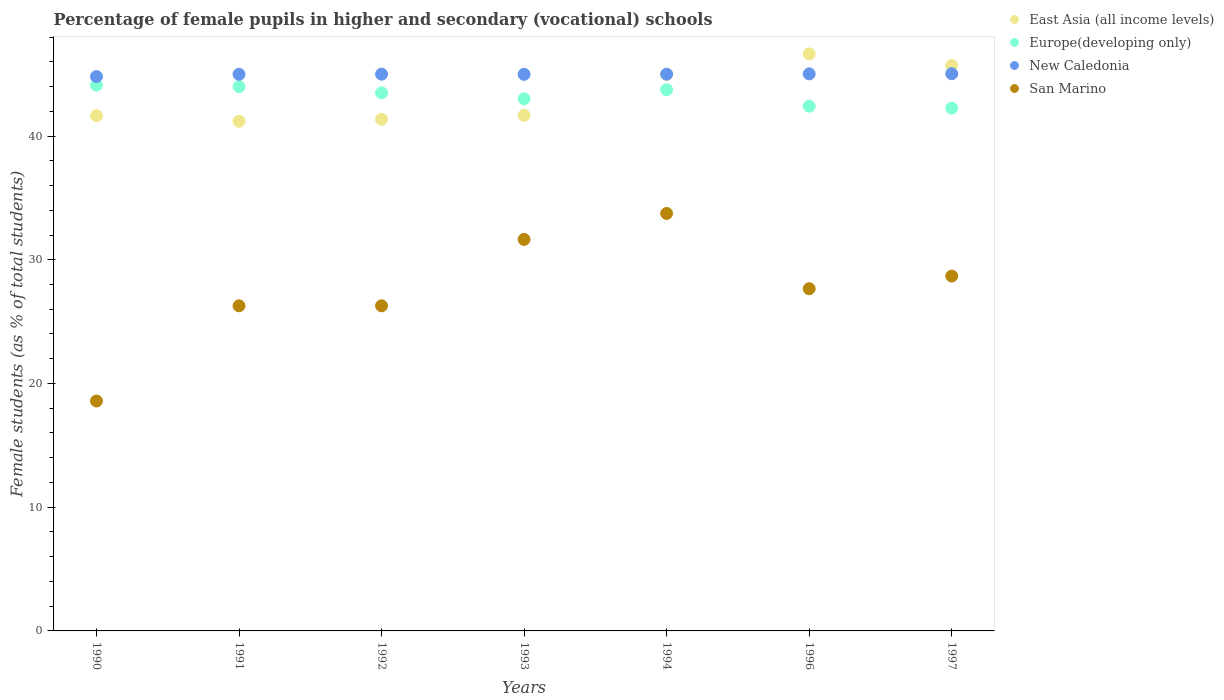Is the number of dotlines equal to the number of legend labels?
Give a very brief answer. Yes. What is the percentage of female pupils in higher and secondary schools in San Marino in 1992?
Your answer should be very brief. 26.28. Across all years, what is the maximum percentage of female pupils in higher and secondary schools in East Asia (all income levels)?
Your answer should be very brief. 46.64. Across all years, what is the minimum percentage of female pupils in higher and secondary schools in San Marino?
Offer a very short reply. 18.58. In which year was the percentage of female pupils in higher and secondary schools in Europe(developing only) maximum?
Provide a succinct answer. 1990. What is the total percentage of female pupils in higher and secondary schools in New Caledonia in the graph?
Keep it short and to the point. 314.85. What is the difference between the percentage of female pupils in higher and secondary schools in East Asia (all income levels) in 1991 and that in 1992?
Provide a succinct answer. -0.16. What is the difference between the percentage of female pupils in higher and secondary schools in San Marino in 1994 and the percentage of female pupils in higher and secondary schools in Europe(developing only) in 1996?
Your response must be concise. -8.67. What is the average percentage of female pupils in higher and secondary schools in East Asia (all income levels) per year?
Your response must be concise. 43.31. In the year 1991, what is the difference between the percentage of female pupils in higher and secondary schools in East Asia (all income levels) and percentage of female pupils in higher and secondary schools in New Caledonia?
Your answer should be compact. -3.8. In how many years, is the percentage of female pupils in higher and secondary schools in New Caledonia greater than 20 %?
Your answer should be compact. 7. What is the ratio of the percentage of female pupils in higher and secondary schools in San Marino in 1993 to that in 1996?
Your answer should be very brief. 1.14. Is the difference between the percentage of female pupils in higher and secondary schools in East Asia (all income levels) in 1991 and 1994 greater than the difference between the percentage of female pupils in higher and secondary schools in New Caledonia in 1991 and 1994?
Your response must be concise. No. What is the difference between the highest and the second highest percentage of female pupils in higher and secondary schools in East Asia (all income levels)?
Offer a terse response. 0.94. What is the difference between the highest and the lowest percentage of female pupils in higher and secondary schools in East Asia (all income levels)?
Offer a terse response. 5.44. Is the percentage of female pupils in higher and secondary schools in San Marino strictly greater than the percentage of female pupils in higher and secondary schools in East Asia (all income levels) over the years?
Provide a succinct answer. No. Is the percentage of female pupils in higher and secondary schools in San Marino strictly less than the percentage of female pupils in higher and secondary schools in Europe(developing only) over the years?
Give a very brief answer. Yes. How many dotlines are there?
Offer a terse response. 4. What is the difference between two consecutive major ticks on the Y-axis?
Offer a very short reply. 10. Are the values on the major ticks of Y-axis written in scientific E-notation?
Give a very brief answer. No. Does the graph contain any zero values?
Your answer should be compact. No. Does the graph contain grids?
Your answer should be very brief. No. Where does the legend appear in the graph?
Make the answer very short. Top right. How are the legend labels stacked?
Your response must be concise. Vertical. What is the title of the graph?
Your response must be concise. Percentage of female pupils in higher and secondary (vocational) schools. Does "Sierra Leone" appear as one of the legend labels in the graph?
Keep it short and to the point. No. What is the label or title of the X-axis?
Provide a short and direct response. Years. What is the label or title of the Y-axis?
Provide a succinct answer. Female students (as % of total students). What is the Female students (as % of total students) of East Asia (all income levels) in 1990?
Your answer should be compact. 41.65. What is the Female students (as % of total students) in Europe(developing only) in 1990?
Give a very brief answer. 44.11. What is the Female students (as % of total students) of New Caledonia in 1990?
Your answer should be compact. 44.81. What is the Female students (as % of total students) in San Marino in 1990?
Give a very brief answer. 18.58. What is the Female students (as % of total students) in East Asia (all income levels) in 1991?
Provide a short and direct response. 41.2. What is the Female students (as % of total students) in Europe(developing only) in 1991?
Make the answer very short. 44. What is the Female students (as % of total students) of New Caledonia in 1991?
Give a very brief answer. 44.99. What is the Female students (as % of total students) of San Marino in 1991?
Your answer should be very brief. 26.28. What is the Female students (as % of total students) of East Asia (all income levels) in 1992?
Keep it short and to the point. 41.35. What is the Female students (as % of total students) in Europe(developing only) in 1992?
Your answer should be compact. 43.49. What is the Female students (as % of total students) in San Marino in 1992?
Provide a short and direct response. 26.28. What is the Female students (as % of total students) in East Asia (all income levels) in 1993?
Keep it short and to the point. 41.68. What is the Female students (as % of total students) of Europe(developing only) in 1993?
Your answer should be very brief. 43.01. What is the Female students (as % of total students) of New Caledonia in 1993?
Your response must be concise. 44.99. What is the Female students (as % of total students) in San Marino in 1993?
Provide a short and direct response. 31.65. What is the Female students (as % of total students) of East Asia (all income levels) in 1994?
Make the answer very short. 44.98. What is the Female students (as % of total students) of Europe(developing only) in 1994?
Your answer should be compact. 43.75. What is the Female students (as % of total students) of New Caledonia in 1994?
Offer a terse response. 45. What is the Female students (as % of total students) of San Marino in 1994?
Provide a succinct answer. 33.74. What is the Female students (as % of total students) of East Asia (all income levels) in 1996?
Your answer should be compact. 46.64. What is the Female students (as % of total students) in Europe(developing only) in 1996?
Your answer should be very brief. 42.41. What is the Female students (as % of total students) in New Caledonia in 1996?
Offer a very short reply. 45.03. What is the Female students (as % of total students) in San Marino in 1996?
Give a very brief answer. 27.66. What is the Female students (as % of total students) in East Asia (all income levels) in 1997?
Give a very brief answer. 45.7. What is the Female students (as % of total students) of Europe(developing only) in 1997?
Your answer should be very brief. 42.26. What is the Female students (as % of total students) of New Caledonia in 1997?
Your answer should be very brief. 45.04. What is the Female students (as % of total students) in San Marino in 1997?
Provide a short and direct response. 28.68. Across all years, what is the maximum Female students (as % of total students) in East Asia (all income levels)?
Offer a very short reply. 46.64. Across all years, what is the maximum Female students (as % of total students) in Europe(developing only)?
Your answer should be very brief. 44.11. Across all years, what is the maximum Female students (as % of total students) in New Caledonia?
Keep it short and to the point. 45.04. Across all years, what is the maximum Female students (as % of total students) of San Marino?
Ensure brevity in your answer.  33.74. Across all years, what is the minimum Female students (as % of total students) in East Asia (all income levels)?
Your answer should be compact. 41.2. Across all years, what is the minimum Female students (as % of total students) in Europe(developing only)?
Give a very brief answer. 42.26. Across all years, what is the minimum Female students (as % of total students) of New Caledonia?
Offer a very short reply. 44.81. Across all years, what is the minimum Female students (as % of total students) in San Marino?
Keep it short and to the point. 18.58. What is the total Female students (as % of total students) in East Asia (all income levels) in the graph?
Give a very brief answer. 303.19. What is the total Female students (as % of total students) in Europe(developing only) in the graph?
Offer a terse response. 303.03. What is the total Female students (as % of total students) in New Caledonia in the graph?
Provide a succinct answer. 314.85. What is the total Female students (as % of total students) in San Marino in the graph?
Keep it short and to the point. 192.87. What is the difference between the Female students (as % of total students) of East Asia (all income levels) in 1990 and that in 1991?
Provide a succinct answer. 0.45. What is the difference between the Female students (as % of total students) in Europe(developing only) in 1990 and that in 1991?
Your answer should be very brief. 0.11. What is the difference between the Female students (as % of total students) in New Caledonia in 1990 and that in 1991?
Provide a succinct answer. -0.19. What is the difference between the Female students (as % of total students) in San Marino in 1990 and that in 1991?
Your response must be concise. -7.69. What is the difference between the Female students (as % of total students) in East Asia (all income levels) in 1990 and that in 1992?
Offer a terse response. 0.29. What is the difference between the Female students (as % of total students) of Europe(developing only) in 1990 and that in 1992?
Provide a succinct answer. 0.62. What is the difference between the Female students (as % of total students) in New Caledonia in 1990 and that in 1992?
Provide a succinct answer. -0.19. What is the difference between the Female students (as % of total students) in San Marino in 1990 and that in 1992?
Keep it short and to the point. -7.69. What is the difference between the Female students (as % of total students) of East Asia (all income levels) in 1990 and that in 1993?
Offer a terse response. -0.03. What is the difference between the Female students (as % of total students) in Europe(developing only) in 1990 and that in 1993?
Make the answer very short. 1.1. What is the difference between the Female students (as % of total students) of New Caledonia in 1990 and that in 1993?
Your response must be concise. -0.18. What is the difference between the Female students (as % of total students) in San Marino in 1990 and that in 1993?
Ensure brevity in your answer.  -13.06. What is the difference between the Female students (as % of total students) in East Asia (all income levels) in 1990 and that in 1994?
Keep it short and to the point. -3.33. What is the difference between the Female students (as % of total students) in Europe(developing only) in 1990 and that in 1994?
Keep it short and to the point. 0.36. What is the difference between the Female students (as % of total students) in New Caledonia in 1990 and that in 1994?
Your answer should be compact. -0.19. What is the difference between the Female students (as % of total students) of San Marino in 1990 and that in 1994?
Ensure brevity in your answer.  -15.16. What is the difference between the Female students (as % of total students) of East Asia (all income levels) in 1990 and that in 1996?
Offer a very short reply. -4.99. What is the difference between the Female students (as % of total students) of Europe(developing only) in 1990 and that in 1996?
Your answer should be compact. 1.7. What is the difference between the Female students (as % of total students) of New Caledonia in 1990 and that in 1996?
Offer a terse response. -0.22. What is the difference between the Female students (as % of total students) of San Marino in 1990 and that in 1996?
Provide a short and direct response. -9.08. What is the difference between the Female students (as % of total students) in East Asia (all income levels) in 1990 and that in 1997?
Provide a short and direct response. -4.05. What is the difference between the Female students (as % of total students) in Europe(developing only) in 1990 and that in 1997?
Provide a succinct answer. 1.85. What is the difference between the Female students (as % of total students) in New Caledonia in 1990 and that in 1997?
Provide a succinct answer. -0.23. What is the difference between the Female students (as % of total students) of San Marino in 1990 and that in 1997?
Your answer should be very brief. -10.1. What is the difference between the Female students (as % of total students) of East Asia (all income levels) in 1991 and that in 1992?
Make the answer very short. -0.16. What is the difference between the Female students (as % of total students) of Europe(developing only) in 1991 and that in 1992?
Your answer should be compact. 0.51. What is the difference between the Female students (as % of total students) in New Caledonia in 1991 and that in 1992?
Offer a terse response. -0.01. What is the difference between the Female students (as % of total students) in San Marino in 1991 and that in 1992?
Make the answer very short. 0. What is the difference between the Female students (as % of total students) of East Asia (all income levels) in 1991 and that in 1993?
Provide a short and direct response. -0.48. What is the difference between the Female students (as % of total students) of Europe(developing only) in 1991 and that in 1993?
Offer a terse response. 0.99. What is the difference between the Female students (as % of total students) in New Caledonia in 1991 and that in 1993?
Offer a very short reply. 0.01. What is the difference between the Female students (as % of total students) of San Marino in 1991 and that in 1993?
Provide a short and direct response. -5.37. What is the difference between the Female students (as % of total students) of East Asia (all income levels) in 1991 and that in 1994?
Provide a short and direct response. -3.79. What is the difference between the Female students (as % of total students) of Europe(developing only) in 1991 and that in 1994?
Make the answer very short. 0.25. What is the difference between the Female students (as % of total students) of New Caledonia in 1991 and that in 1994?
Offer a very short reply. -0.01. What is the difference between the Female students (as % of total students) in San Marino in 1991 and that in 1994?
Provide a succinct answer. -7.46. What is the difference between the Female students (as % of total students) of East Asia (all income levels) in 1991 and that in 1996?
Your response must be concise. -5.44. What is the difference between the Female students (as % of total students) in Europe(developing only) in 1991 and that in 1996?
Your answer should be very brief. 1.59. What is the difference between the Female students (as % of total students) in New Caledonia in 1991 and that in 1996?
Keep it short and to the point. -0.03. What is the difference between the Female students (as % of total students) in San Marino in 1991 and that in 1996?
Keep it short and to the point. -1.38. What is the difference between the Female students (as % of total students) of East Asia (all income levels) in 1991 and that in 1997?
Provide a short and direct response. -4.51. What is the difference between the Female students (as % of total students) of Europe(developing only) in 1991 and that in 1997?
Your response must be concise. 1.74. What is the difference between the Female students (as % of total students) of New Caledonia in 1991 and that in 1997?
Provide a short and direct response. -0.05. What is the difference between the Female students (as % of total students) of San Marino in 1991 and that in 1997?
Offer a very short reply. -2.4. What is the difference between the Female students (as % of total students) in East Asia (all income levels) in 1992 and that in 1993?
Provide a succinct answer. -0.32. What is the difference between the Female students (as % of total students) in Europe(developing only) in 1992 and that in 1993?
Offer a very short reply. 0.48. What is the difference between the Female students (as % of total students) of New Caledonia in 1992 and that in 1993?
Provide a succinct answer. 0.01. What is the difference between the Female students (as % of total students) in San Marino in 1992 and that in 1993?
Your answer should be very brief. -5.37. What is the difference between the Female students (as % of total students) in East Asia (all income levels) in 1992 and that in 1994?
Provide a succinct answer. -3.63. What is the difference between the Female students (as % of total students) in Europe(developing only) in 1992 and that in 1994?
Keep it short and to the point. -0.26. What is the difference between the Female students (as % of total students) of San Marino in 1992 and that in 1994?
Your answer should be very brief. -7.46. What is the difference between the Female students (as % of total students) in East Asia (all income levels) in 1992 and that in 1996?
Your response must be concise. -5.28. What is the difference between the Female students (as % of total students) of Europe(developing only) in 1992 and that in 1996?
Your response must be concise. 1.08. What is the difference between the Female students (as % of total students) in New Caledonia in 1992 and that in 1996?
Your answer should be very brief. -0.03. What is the difference between the Female students (as % of total students) of San Marino in 1992 and that in 1996?
Keep it short and to the point. -1.38. What is the difference between the Female students (as % of total students) in East Asia (all income levels) in 1992 and that in 1997?
Your answer should be compact. -4.35. What is the difference between the Female students (as % of total students) of Europe(developing only) in 1992 and that in 1997?
Offer a very short reply. 1.23. What is the difference between the Female students (as % of total students) of New Caledonia in 1992 and that in 1997?
Offer a very short reply. -0.04. What is the difference between the Female students (as % of total students) of San Marino in 1992 and that in 1997?
Your response must be concise. -2.4. What is the difference between the Female students (as % of total students) of East Asia (all income levels) in 1993 and that in 1994?
Keep it short and to the point. -3.3. What is the difference between the Female students (as % of total students) in Europe(developing only) in 1993 and that in 1994?
Your response must be concise. -0.74. What is the difference between the Female students (as % of total students) in New Caledonia in 1993 and that in 1994?
Keep it short and to the point. -0.01. What is the difference between the Female students (as % of total students) in San Marino in 1993 and that in 1994?
Your answer should be compact. -2.1. What is the difference between the Female students (as % of total students) of East Asia (all income levels) in 1993 and that in 1996?
Your answer should be compact. -4.96. What is the difference between the Female students (as % of total students) of Europe(developing only) in 1993 and that in 1996?
Ensure brevity in your answer.  0.59. What is the difference between the Female students (as % of total students) in New Caledonia in 1993 and that in 1996?
Offer a terse response. -0.04. What is the difference between the Female students (as % of total students) in San Marino in 1993 and that in 1996?
Make the answer very short. 3.99. What is the difference between the Female students (as % of total students) of East Asia (all income levels) in 1993 and that in 1997?
Offer a very short reply. -4.02. What is the difference between the Female students (as % of total students) in Europe(developing only) in 1993 and that in 1997?
Provide a short and direct response. 0.75. What is the difference between the Female students (as % of total students) of New Caledonia in 1993 and that in 1997?
Offer a terse response. -0.05. What is the difference between the Female students (as % of total students) of San Marino in 1993 and that in 1997?
Make the answer very short. 2.96. What is the difference between the Female students (as % of total students) in East Asia (all income levels) in 1994 and that in 1996?
Ensure brevity in your answer.  -1.65. What is the difference between the Female students (as % of total students) in Europe(developing only) in 1994 and that in 1996?
Your response must be concise. 1.33. What is the difference between the Female students (as % of total students) in New Caledonia in 1994 and that in 1996?
Your response must be concise. -0.03. What is the difference between the Female students (as % of total students) in San Marino in 1994 and that in 1996?
Keep it short and to the point. 6.08. What is the difference between the Female students (as % of total students) of East Asia (all income levels) in 1994 and that in 1997?
Make the answer very short. -0.72. What is the difference between the Female students (as % of total students) in Europe(developing only) in 1994 and that in 1997?
Your answer should be compact. 1.49. What is the difference between the Female students (as % of total students) of New Caledonia in 1994 and that in 1997?
Offer a terse response. -0.04. What is the difference between the Female students (as % of total students) in San Marino in 1994 and that in 1997?
Your answer should be very brief. 5.06. What is the difference between the Female students (as % of total students) in East Asia (all income levels) in 1996 and that in 1997?
Give a very brief answer. 0.94. What is the difference between the Female students (as % of total students) in Europe(developing only) in 1996 and that in 1997?
Your answer should be compact. 0.16. What is the difference between the Female students (as % of total students) of New Caledonia in 1996 and that in 1997?
Ensure brevity in your answer.  -0.01. What is the difference between the Female students (as % of total students) in San Marino in 1996 and that in 1997?
Give a very brief answer. -1.02. What is the difference between the Female students (as % of total students) in East Asia (all income levels) in 1990 and the Female students (as % of total students) in Europe(developing only) in 1991?
Provide a short and direct response. -2.35. What is the difference between the Female students (as % of total students) in East Asia (all income levels) in 1990 and the Female students (as % of total students) in New Caledonia in 1991?
Your answer should be compact. -3.34. What is the difference between the Female students (as % of total students) of East Asia (all income levels) in 1990 and the Female students (as % of total students) of San Marino in 1991?
Keep it short and to the point. 15.37. What is the difference between the Female students (as % of total students) of Europe(developing only) in 1990 and the Female students (as % of total students) of New Caledonia in 1991?
Provide a short and direct response. -0.88. What is the difference between the Female students (as % of total students) in Europe(developing only) in 1990 and the Female students (as % of total students) in San Marino in 1991?
Provide a succinct answer. 17.83. What is the difference between the Female students (as % of total students) of New Caledonia in 1990 and the Female students (as % of total students) of San Marino in 1991?
Keep it short and to the point. 18.53. What is the difference between the Female students (as % of total students) in East Asia (all income levels) in 1990 and the Female students (as % of total students) in Europe(developing only) in 1992?
Provide a short and direct response. -1.84. What is the difference between the Female students (as % of total students) in East Asia (all income levels) in 1990 and the Female students (as % of total students) in New Caledonia in 1992?
Provide a succinct answer. -3.35. What is the difference between the Female students (as % of total students) in East Asia (all income levels) in 1990 and the Female students (as % of total students) in San Marino in 1992?
Make the answer very short. 15.37. What is the difference between the Female students (as % of total students) of Europe(developing only) in 1990 and the Female students (as % of total students) of New Caledonia in 1992?
Offer a very short reply. -0.89. What is the difference between the Female students (as % of total students) in Europe(developing only) in 1990 and the Female students (as % of total students) in San Marino in 1992?
Keep it short and to the point. 17.83. What is the difference between the Female students (as % of total students) of New Caledonia in 1990 and the Female students (as % of total students) of San Marino in 1992?
Your answer should be very brief. 18.53. What is the difference between the Female students (as % of total students) in East Asia (all income levels) in 1990 and the Female students (as % of total students) in Europe(developing only) in 1993?
Ensure brevity in your answer.  -1.36. What is the difference between the Female students (as % of total students) of East Asia (all income levels) in 1990 and the Female students (as % of total students) of New Caledonia in 1993?
Your answer should be compact. -3.34. What is the difference between the Female students (as % of total students) of East Asia (all income levels) in 1990 and the Female students (as % of total students) of San Marino in 1993?
Your response must be concise. 10. What is the difference between the Female students (as % of total students) of Europe(developing only) in 1990 and the Female students (as % of total students) of New Caledonia in 1993?
Provide a short and direct response. -0.88. What is the difference between the Female students (as % of total students) of Europe(developing only) in 1990 and the Female students (as % of total students) of San Marino in 1993?
Your response must be concise. 12.47. What is the difference between the Female students (as % of total students) of New Caledonia in 1990 and the Female students (as % of total students) of San Marino in 1993?
Offer a terse response. 13.16. What is the difference between the Female students (as % of total students) in East Asia (all income levels) in 1990 and the Female students (as % of total students) in Europe(developing only) in 1994?
Give a very brief answer. -2.1. What is the difference between the Female students (as % of total students) of East Asia (all income levels) in 1990 and the Female students (as % of total students) of New Caledonia in 1994?
Make the answer very short. -3.35. What is the difference between the Female students (as % of total students) in East Asia (all income levels) in 1990 and the Female students (as % of total students) in San Marino in 1994?
Provide a succinct answer. 7.91. What is the difference between the Female students (as % of total students) in Europe(developing only) in 1990 and the Female students (as % of total students) in New Caledonia in 1994?
Your response must be concise. -0.89. What is the difference between the Female students (as % of total students) in Europe(developing only) in 1990 and the Female students (as % of total students) in San Marino in 1994?
Offer a very short reply. 10.37. What is the difference between the Female students (as % of total students) of New Caledonia in 1990 and the Female students (as % of total students) of San Marino in 1994?
Offer a very short reply. 11.06. What is the difference between the Female students (as % of total students) in East Asia (all income levels) in 1990 and the Female students (as % of total students) in Europe(developing only) in 1996?
Ensure brevity in your answer.  -0.77. What is the difference between the Female students (as % of total students) in East Asia (all income levels) in 1990 and the Female students (as % of total students) in New Caledonia in 1996?
Give a very brief answer. -3.38. What is the difference between the Female students (as % of total students) of East Asia (all income levels) in 1990 and the Female students (as % of total students) of San Marino in 1996?
Offer a very short reply. 13.99. What is the difference between the Female students (as % of total students) in Europe(developing only) in 1990 and the Female students (as % of total students) in New Caledonia in 1996?
Your answer should be compact. -0.91. What is the difference between the Female students (as % of total students) in Europe(developing only) in 1990 and the Female students (as % of total students) in San Marino in 1996?
Keep it short and to the point. 16.45. What is the difference between the Female students (as % of total students) of New Caledonia in 1990 and the Female students (as % of total students) of San Marino in 1996?
Your answer should be compact. 17.15. What is the difference between the Female students (as % of total students) in East Asia (all income levels) in 1990 and the Female students (as % of total students) in Europe(developing only) in 1997?
Make the answer very short. -0.61. What is the difference between the Female students (as % of total students) in East Asia (all income levels) in 1990 and the Female students (as % of total students) in New Caledonia in 1997?
Your response must be concise. -3.39. What is the difference between the Female students (as % of total students) in East Asia (all income levels) in 1990 and the Female students (as % of total students) in San Marino in 1997?
Provide a short and direct response. 12.97. What is the difference between the Female students (as % of total students) in Europe(developing only) in 1990 and the Female students (as % of total students) in New Caledonia in 1997?
Provide a short and direct response. -0.93. What is the difference between the Female students (as % of total students) in Europe(developing only) in 1990 and the Female students (as % of total students) in San Marino in 1997?
Make the answer very short. 15.43. What is the difference between the Female students (as % of total students) in New Caledonia in 1990 and the Female students (as % of total students) in San Marino in 1997?
Your answer should be compact. 16.12. What is the difference between the Female students (as % of total students) in East Asia (all income levels) in 1991 and the Female students (as % of total students) in Europe(developing only) in 1992?
Provide a succinct answer. -2.3. What is the difference between the Female students (as % of total students) in East Asia (all income levels) in 1991 and the Female students (as % of total students) in New Caledonia in 1992?
Offer a very short reply. -3.8. What is the difference between the Female students (as % of total students) in East Asia (all income levels) in 1991 and the Female students (as % of total students) in San Marino in 1992?
Make the answer very short. 14.92. What is the difference between the Female students (as % of total students) of Europe(developing only) in 1991 and the Female students (as % of total students) of New Caledonia in 1992?
Make the answer very short. -1. What is the difference between the Female students (as % of total students) of Europe(developing only) in 1991 and the Female students (as % of total students) of San Marino in 1992?
Provide a succinct answer. 17.72. What is the difference between the Female students (as % of total students) of New Caledonia in 1991 and the Female students (as % of total students) of San Marino in 1992?
Give a very brief answer. 18.71. What is the difference between the Female students (as % of total students) in East Asia (all income levels) in 1991 and the Female students (as % of total students) in Europe(developing only) in 1993?
Provide a short and direct response. -1.81. What is the difference between the Female students (as % of total students) of East Asia (all income levels) in 1991 and the Female students (as % of total students) of New Caledonia in 1993?
Make the answer very short. -3.79. What is the difference between the Female students (as % of total students) of East Asia (all income levels) in 1991 and the Female students (as % of total students) of San Marino in 1993?
Offer a very short reply. 9.55. What is the difference between the Female students (as % of total students) of Europe(developing only) in 1991 and the Female students (as % of total students) of New Caledonia in 1993?
Your answer should be very brief. -0.99. What is the difference between the Female students (as % of total students) of Europe(developing only) in 1991 and the Female students (as % of total students) of San Marino in 1993?
Offer a terse response. 12.36. What is the difference between the Female students (as % of total students) in New Caledonia in 1991 and the Female students (as % of total students) in San Marino in 1993?
Give a very brief answer. 13.35. What is the difference between the Female students (as % of total students) of East Asia (all income levels) in 1991 and the Female students (as % of total students) of Europe(developing only) in 1994?
Give a very brief answer. -2.55. What is the difference between the Female students (as % of total students) of East Asia (all income levels) in 1991 and the Female students (as % of total students) of New Caledonia in 1994?
Keep it short and to the point. -3.8. What is the difference between the Female students (as % of total students) of East Asia (all income levels) in 1991 and the Female students (as % of total students) of San Marino in 1994?
Your answer should be compact. 7.45. What is the difference between the Female students (as % of total students) in Europe(developing only) in 1991 and the Female students (as % of total students) in New Caledonia in 1994?
Ensure brevity in your answer.  -1. What is the difference between the Female students (as % of total students) of Europe(developing only) in 1991 and the Female students (as % of total students) of San Marino in 1994?
Offer a very short reply. 10.26. What is the difference between the Female students (as % of total students) in New Caledonia in 1991 and the Female students (as % of total students) in San Marino in 1994?
Make the answer very short. 11.25. What is the difference between the Female students (as % of total students) of East Asia (all income levels) in 1991 and the Female students (as % of total students) of Europe(developing only) in 1996?
Provide a short and direct response. -1.22. What is the difference between the Female students (as % of total students) in East Asia (all income levels) in 1991 and the Female students (as % of total students) in New Caledonia in 1996?
Ensure brevity in your answer.  -3.83. What is the difference between the Female students (as % of total students) of East Asia (all income levels) in 1991 and the Female students (as % of total students) of San Marino in 1996?
Your answer should be compact. 13.54. What is the difference between the Female students (as % of total students) of Europe(developing only) in 1991 and the Female students (as % of total students) of New Caledonia in 1996?
Keep it short and to the point. -1.02. What is the difference between the Female students (as % of total students) of Europe(developing only) in 1991 and the Female students (as % of total students) of San Marino in 1996?
Make the answer very short. 16.34. What is the difference between the Female students (as % of total students) in New Caledonia in 1991 and the Female students (as % of total students) in San Marino in 1996?
Offer a terse response. 17.33. What is the difference between the Female students (as % of total students) in East Asia (all income levels) in 1991 and the Female students (as % of total students) in Europe(developing only) in 1997?
Your response must be concise. -1.06. What is the difference between the Female students (as % of total students) in East Asia (all income levels) in 1991 and the Female students (as % of total students) in New Caledonia in 1997?
Offer a very short reply. -3.84. What is the difference between the Female students (as % of total students) of East Asia (all income levels) in 1991 and the Female students (as % of total students) of San Marino in 1997?
Your answer should be compact. 12.51. What is the difference between the Female students (as % of total students) in Europe(developing only) in 1991 and the Female students (as % of total students) in New Caledonia in 1997?
Give a very brief answer. -1.04. What is the difference between the Female students (as % of total students) in Europe(developing only) in 1991 and the Female students (as % of total students) in San Marino in 1997?
Offer a very short reply. 15.32. What is the difference between the Female students (as % of total students) in New Caledonia in 1991 and the Female students (as % of total students) in San Marino in 1997?
Provide a succinct answer. 16.31. What is the difference between the Female students (as % of total students) of East Asia (all income levels) in 1992 and the Female students (as % of total students) of Europe(developing only) in 1993?
Your answer should be compact. -1.65. What is the difference between the Female students (as % of total students) in East Asia (all income levels) in 1992 and the Female students (as % of total students) in New Caledonia in 1993?
Provide a short and direct response. -3.63. What is the difference between the Female students (as % of total students) of East Asia (all income levels) in 1992 and the Female students (as % of total students) of San Marino in 1993?
Make the answer very short. 9.71. What is the difference between the Female students (as % of total students) of Europe(developing only) in 1992 and the Female students (as % of total students) of New Caledonia in 1993?
Offer a very short reply. -1.5. What is the difference between the Female students (as % of total students) of Europe(developing only) in 1992 and the Female students (as % of total students) of San Marino in 1993?
Keep it short and to the point. 11.84. What is the difference between the Female students (as % of total students) in New Caledonia in 1992 and the Female students (as % of total students) in San Marino in 1993?
Your answer should be compact. 13.35. What is the difference between the Female students (as % of total students) of East Asia (all income levels) in 1992 and the Female students (as % of total students) of Europe(developing only) in 1994?
Provide a short and direct response. -2.39. What is the difference between the Female students (as % of total students) of East Asia (all income levels) in 1992 and the Female students (as % of total students) of New Caledonia in 1994?
Offer a very short reply. -3.65. What is the difference between the Female students (as % of total students) of East Asia (all income levels) in 1992 and the Female students (as % of total students) of San Marino in 1994?
Offer a terse response. 7.61. What is the difference between the Female students (as % of total students) in Europe(developing only) in 1992 and the Female students (as % of total students) in New Caledonia in 1994?
Make the answer very short. -1.51. What is the difference between the Female students (as % of total students) in Europe(developing only) in 1992 and the Female students (as % of total students) in San Marino in 1994?
Give a very brief answer. 9.75. What is the difference between the Female students (as % of total students) of New Caledonia in 1992 and the Female students (as % of total students) of San Marino in 1994?
Provide a succinct answer. 11.26. What is the difference between the Female students (as % of total students) of East Asia (all income levels) in 1992 and the Female students (as % of total students) of Europe(developing only) in 1996?
Your response must be concise. -1.06. What is the difference between the Female students (as % of total students) in East Asia (all income levels) in 1992 and the Female students (as % of total students) in New Caledonia in 1996?
Offer a terse response. -3.67. What is the difference between the Female students (as % of total students) of East Asia (all income levels) in 1992 and the Female students (as % of total students) of San Marino in 1996?
Offer a very short reply. 13.7. What is the difference between the Female students (as % of total students) of Europe(developing only) in 1992 and the Female students (as % of total students) of New Caledonia in 1996?
Ensure brevity in your answer.  -1.54. What is the difference between the Female students (as % of total students) in Europe(developing only) in 1992 and the Female students (as % of total students) in San Marino in 1996?
Ensure brevity in your answer.  15.83. What is the difference between the Female students (as % of total students) in New Caledonia in 1992 and the Female students (as % of total students) in San Marino in 1996?
Offer a very short reply. 17.34. What is the difference between the Female students (as % of total students) of East Asia (all income levels) in 1992 and the Female students (as % of total students) of Europe(developing only) in 1997?
Your answer should be very brief. -0.9. What is the difference between the Female students (as % of total students) in East Asia (all income levels) in 1992 and the Female students (as % of total students) in New Caledonia in 1997?
Keep it short and to the point. -3.68. What is the difference between the Female students (as % of total students) in East Asia (all income levels) in 1992 and the Female students (as % of total students) in San Marino in 1997?
Your response must be concise. 12.67. What is the difference between the Female students (as % of total students) in Europe(developing only) in 1992 and the Female students (as % of total students) in New Caledonia in 1997?
Give a very brief answer. -1.55. What is the difference between the Female students (as % of total students) in Europe(developing only) in 1992 and the Female students (as % of total students) in San Marino in 1997?
Your answer should be very brief. 14.81. What is the difference between the Female students (as % of total students) of New Caledonia in 1992 and the Female students (as % of total students) of San Marino in 1997?
Make the answer very short. 16.32. What is the difference between the Female students (as % of total students) in East Asia (all income levels) in 1993 and the Female students (as % of total students) in Europe(developing only) in 1994?
Provide a short and direct response. -2.07. What is the difference between the Female students (as % of total students) in East Asia (all income levels) in 1993 and the Female students (as % of total students) in New Caledonia in 1994?
Ensure brevity in your answer.  -3.32. What is the difference between the Female students (as % of total students) in East Asia (all income levels) in 1993 and the Female students (as % of total students) in San Marino in 1994?
Your response must be concise. 7.93. What is the difference between the Female students (as % of total students) in Europe(developing only) in 1993 and the Female students (as % of total students) in New Caledonia in 1994?
Make the answer very short. -1.99. What is the difference between the Female students (as % of total students) in Europe(developing only) in 1993 and the Female students (as % of total students) in San Marino in 1994?
Keep it short and to the point. 9.27. What is the difference between the Female students (as % of total students) of New Caledonia in 1993 and the Female students (as % of total students) of San Marino in 1994?
Keep it short and to the point. 11.24. What is the difference between the Female students (as % of total students) in East Asia (all income levels) in 1993 and the Female students (as % of total students) in Europe(developing only) in 1996?
Keep it short and to the point. -0.74. What is the difference between the Female students (as % of total students) in East Asia (all income levels) in 1993 and the Female students (as % of total students) in New Caledonia in 1996?
Provide a short and direct response. -3.35. What is the difference between the Female students (as % of total students) of East Asia (all income levels) in 1993 and the Female students (as % of total students) of San Marino in 1996?
Keep it short and to the point. 14.02. What is the difference between the Female students (as % of total students) in Europe(developing only) in 1993 and the Female students (as % of total students) in New Caledonia in 1996?
Your answer should be compact. -2.02. What is the difference between the Female students (as % of total students) of Europe(developing only) in 1993 and the Female students (as % of total students) of San Marino in 1996?
Ensure brevity in your answer.  15.35. What is the difference between the Female students (as % of total students) in New Caledonia in 1993 and the Female students (as % of total students) in San Marino in 1996?
Make the answer very short. 17.33. What is the difference between the Female students (as % of total students) in East Asia (all income levels) in 1993 and the Female students (as % of total students) in Europe(developing only) in 1997?
Offer a terse response. -0.58. What is the difference between the Female students (as % of total students) in East Asia (all income levels) in 1993 and the Female students (as % of total students) in New Caledonia in 1997?
Provide a succinct answer. -3.36. What is the difference between the Female students (as % of total students) of East Asia (all income levels) in 1993 and the Female students (as % of total students) of San Marino in 1997?
Give a very brief answer. 12.99. What is the difference between the Female students (as % of total students) of Europe(developing only) in 1993 and the Female students (as % of total students) of New Caledonia in 1997?
Your response must be concise. -2.03. What is the difference between the Female students (as % of total students) in Europe(developing only) in 1993 and the Female students (as % of total students) in San Marino in 1997?
Offer a terse response. 14.33. What is the difference between the Female students (as % of total students) of New Caledonia in 1993 and the Female students (as % of total students) of San Marino in 1997?
Offer a terse response. 16.3. What is the difference between the Female students (as % of total students) in East Asia (all income levels) in 1994 and the Female students (as % of total students) in Europe(developing only) in 1996?
Give a very brief answer. 2.57. What is the difference between the Female students (as % of total students) of East Asia (all income levels) in 1994 and the Female students (as % of total students) of New Caledonia in 1996?
Your response must be concise. -0.04. What is the difference between the Female students (as % of total students) in East Asia (all income levels) in 1994 and the Female students (as % of total students) in San Marino in 1996?
Your answer should be very brief. 17.32. What is the difference between the Female students (as % of total students) in Europe(developing only) in 1994 and the Female students (as % of total students) in New Caledonia in 1996?
Make the answer very short. -1.28. What is the difference between the Female students (as % of total students) of Europe(developing only) in 1994 and the Female students (as % of total students) of San Marino in 1996?
Provide a short and direct response. 16.09. What is the difference between the Female students (as % of total students) of New Caledonia in 1994 and the Female students (as % of total students) of San Marino in 1996?
Ensure brevity in your answer.  17.34. What is the difference between the Female students (as % of total students) in East Asia (all income levels) in 1994 and the Female students (as % of total students) in Europe(developing only) in 1997?
Keep it short and to the point. 2.72. What is the difference between the Female students (as % of total students) in East Asia (all income levels) in 1994 and the Female students (as % of total students) in New Caledonia in 1997?
Keep it short and to the point. -0.06. What is the difference between the Female students (as % of total students) in East Asia (all income levels) in 1994 and the Female students (as % of total students) in San Marino in 1997?
Ensure brevity in your answer.  16.3. What is the difference between the Female students (as % of total students) of Europe(developing only) in 1994 and the Female students (as % of total students) of New Caledonia in 1997?
Ensure brevity in your answer.  -1.29. What is the difference between the Female students (as % of total students) of Europe(developing only) in 1994 and the Female students (as % of total students) of San Marino in 1997?
Keep it short and to the point. 15.06. What is the difference between the Female students (as % of total students) of New Caledonia in 1994 and the Female students (as % of total students) of San Marino in 1997?
Ensure brevity in your answer.  16.32. What is the difference between the Female students (as % of total students) of East Asia (all income levels) in 1996 and the Female students (as % of total students) of Europe(developing only) in 1997?
Your answer should be compact. 4.38. What is the difference between the Female students (as % of total students) in East Asia (all income levels) in 1996 and the Female students (as % of total students) in New Caledonia in 1997?
Ensure brevity in your answer.  1.6. What is the difference between the Female students (as % of total students) of East Asia (all income levels) in 1996 and the Female students (as % of total students) of San Marino in 1997?
Offer a very short reply. 17.95. What is the difference between the Female students (as % of total students) in Europe(developing only) in 1996 and the Female students (as % of total students) in New Caledonia in 1997?
Your response must be concise. -2.62. What is the difference between the Female students (as % of total students) of Europe(developing only) in 1996 and the Female students (as % of total students) of San Marino in 1997?
Provide a short and direct response. 13.73. What is the difference between the Female students (as % of total students) in New Caledonia in 1996 and the Female students (as % of total students) in San Marino in 1997?
Your response must be concise. 16.34. What is the average Female students (as % of total students) in East Asia (all income levels) per year?
Your response must be concise. 43.31. What is the average Female students (as % of total students) of Europe(developing only) per year?
Make the answer very short. 43.29. What is the average Female students (as % of total students) of New Caledonia per year?
Keep it short and to the point. 44.98. What is the average Female students (as % of total students) in San Marino per year?
Give a very brief answer. 27.55. In the year 1990, what is the difference between the Female students (as % of total students) of East Asia (all income levels) and Female students (as % of total students) of Europe(developing only)?
Ensure brevity in your answer.  -2.46. In the year 1990, what is the difference between the Female students (as % of total students) of East Asia (all income levels) and Female students (as % of total students) of New Caledonia?
Your answer should be compact. -3.16. In the year 1990, what is the difference between the Female students (as % of total students) of East Asia (all income levels) and Female students (as % of total students) of San Marino?
Give a very brief answer. 23.06. In the year 1990, what is the difference between the Female students (as % of total students) of Europe(developing only) and Female students (as % of total students) of New Caledonia?
Keep it short and to the point. -0.7. In the year 1990, what is the difference between the Female students (as % of total students) in Europe(developing only) and Female students (as % of total students) in San Marino?
Keep it short and to the point. 25.53. In the year 1990, what is the difference between the Female students (as % of total students) in New Caledonia and Female students (as % of total students) in San Marino?
Give a very brief answer. 26.22. In the year 1991, what is the difference between the Female students (as % of total students) in East Asia (all income levels) and Female students (as % of total students) in Europe(developing only)?
Ensure brevity in your answer.  -2.81. In the year 1991, what is the difference between the Female students (as % of total students) in East Asia (all income levels) and Female students (as % of total students) in New Caledonia?
Keep it short and to the point. -3.8. In the year 1991, what is the difference between the Female students (as % of total students) of East Asia (all income levels) and Female students (as % of total students) of San Marino?
Ensure brevity in your answer.  14.92. In the year 1991, what is the difference between the Female students (as % of total students) of Europe(developing only) and Female students (as % of total students) of New Caledonia?
Give a very brief answer. -0.99. In the year 1991, what is the difference between the Female students (as % of total students) of Europe(developing only) and Female students (as % of total students) of San Marino?
Offer a very short reply. 17.72. In the year 1991, what is the difference between the Female students (as % of total students) of New Caledonia and Female students (as % of total students) of San Marino?
Keep it short and to the point. 18.71. In the year 1992, what is the difference between the Female students (as % of total students) of East Asia (all income levels) and Female students (as % of total students) of Europe(developing only)?
Keep it short and to the point. -2.14. In the year 1992, what is the difference between the Female students (as % of total students) of East Asia (all income levels) and Female students (as % of total students) of New Caledonia?
Give a very brief answer. -3.65. In the year 1992, what is the difference between the Female students (as % of total students) of East Asia (all income levels) and Female students (as % of total students) of San Marino?
Give a very brief answer. 15.08. In the year 1992, what is the difference between the Female students (as % of total students) in Europe(developing only) and Female students (as % of total students) in New Caledonia?
Offer a very short reply. -1.51. In the year 1992, what is the difference between the Female students (as % of total students) of Europe(developing only) and Female students (as % of total students) of San Marino?
Provide a short and direct response. 17.21. In the year 1992, what is the difference between the Female students (as % of total students) of New Caledonia and Female students (as % of total students) of San Marino?
Keep it short and to the point. 18.72. In the year 1993, what is the difference between the Female students (as % of total students) in East Asia (all income levels) and Female students (as % of total students) in Europe(developing only)?
Offer a very short reply. -1.33. In the year 1993, what is the difference between the Female students (as % of total students) in East Asia (all income levels) and Female students (as % of total students) in New Caledonia?
Your response must be concise. -3.31. In the year 1993, what is the difference between the Female students (as % of total students) of East Asia (all income levels) and Female students (as % of total students) of San Marino?
Your answer should be very brief. 10.03. In the year 1993, what is the difference between the Female students (as % of total students) in Europe(developing only) and Female students (as % of total students) in New Caledonia?
Make the answer very short. -1.98. In the year 1993, what is the difference between the Female students (as % of total students) of Europe(developing only) and Female students (as % of total students) of San Marino?
Ensure brevity in your answer.  11.36. In the year 1993, what is the difference between the Female students (as % of total students) of New Caledonia and Female students (as % of total students) of San Marino?
Your answer should be compact. 13.34. In the year 1994, what is the difference between the Female students (as % of total students) of East Asia (all income levels) and Female students (as % of total students) of Europe(developing only)?
Ensure brevity in your answer.  1.23. In the year 1994, what is the difference between the Female students (as % of total students) of East Asia (all income levels) and Female students (as % of total students) of New Caledonia?
Offer a terse response. -0.02. In the year 1994, what is the difference between the Female students (as % of total students) in East Asia (all income levels) and Female students (as % of total students) in San Marino?
Your response must be concise. 11.24. In the year 1994, what is the difference between the Female students (as % of total students) of Europe(developing only) and Female students (as % of total students) of New Caledonia?
Your answer should be compact. -1.25. In the year 1994, what is the difference between the Female students (as % of total students) of Europe(developing only) and Female students (as % of total students) of San Marino?
Keep it short and to the point. 10. In the year 1994, what is the difference between the Female students (as % of total students) of New Caledonia and Female students (as % of total students) of San Marino?
Ensure brevity in your answer.  11.26. In the year 1996, what is the difference between the Female students (as % of total students) of East Asia (all income levels) and Female students (as % of total students) of Europe(developing only)?
Your response must be concise. 4.22. In the year 1996, what is the difference between the Female students (as % of total students) in East Asia (all income levels) and Female students (as % of total students) in New Caledonia?
Your answer should be compact. 1.61. In the year 1996, what is the difference between the Female students (as % of total students) in East Asia (all income levels) and Female students (as % of total students) in San Marino?
Your answer should be very brief. 18.98. In the year 1996, what is the difference between the Female students (as % of total students) in Europe(developing only) and Female students (as % of total students) in New Caledonia?
Your answer should be very brief. -2.61. In the year 1996, what is the difference between the Female students (as % of total students) in Europe(developing only) and Female students (as % of total students) in San Marino?
Provide a succinct answer. 14.75. In the year 1996, what is the difference between the Female students (as % of total students) of New Caledonia and Female students (as % of total students) of San Marino?
Your answer should be very brief. 17.37. In the year 1997, what is the difference between the Female students (as % of total students) in East Asia (all income levels) and Female students (as % of total students) in Europe(developing only)?
Your answer should be very brief. 3.44. In the year 1997, what is the difference between the Female students (as % of total students) in East Asia (all income levels) and Female students (as % of total students) in New Caledonia?
Offer a very short reply. 0.66. In the year 1997, what is the difference between the Female students (as % of total students) of East Asia (all income levels) and Female students (as % of total students) of San Marino?
Provide a short and direct response. 17.02. In the year 1997, what is the difference between the Female students (as % of total students) of Europe(developing only) and Female students (as % of total students) of New Caledonia?
Make the answer very short. -2.78. In the year 1997, what is the difference between the Female students (as % of total students) in Europe(developing only) and Female students (as % of total students) in San Marino?
Ensure brevity in your answer.  13.57. In the year 1997, what is the difference between the Female students (as % of total students) of New Caledonia and Female students (as % of total students) of San Marino?
Provide a succinct answer. 16.36. What is the ratio of the Female students (as % of total students) of East Asia (all income levels) in 1990 to that in 1991?
Offer a terse response. 1.01. What is the ratio of the Female students (as % of total students) in New Caledonia in 1990 to that in 1991?
Make the answer very short. 1. What is the ratio of the Female students (as % of total students) of San Marino in 1990 to that in 1991?
Provide a succinct answer. 0.71. What is the ratio of the Female students (as % of total students) in East Asia (all income levels) in 1990 to that in 1992?
Provide a short and direct response. 1.01. What is the ratio of the Female students (as % of total students) in Europe(developing only) in 1990 to that in 1992?
Offer a terse response. 1.01. What is the ratio of the Female students (as % of total students) of New Caledonia in 1990 to that in 1992?
Ensure brevity in your answer.  1. What is the ratio of the Female students (as % of total students) of San Marino in 1990 to that in 1992?
Provide a short and direct response. 0.71. What is the ratio of the Female students (as % of total students) in East Asia (all income levels) in 1990 to that in 1993?
Ensure brevity in your answer.  1. What is the ratio of the Female students (as % of total students) in Europe(developing only) in 1990 to that in 1993?
Keep it short and to the point. 1.03. What is the ratio of the Female students (as % of total students) in San Marino in 1990 to that in 1993?
Keep it short and to the point. 0.59. What is the ratio of the Female students (as % of total students) in East Asia (all income levels) in 1990 to that in 1994?
Make the answer very short. 0.93. What is the ratio of the Female students (as % of total students) in Europe(developing only) in 1990 to that in 1994?
Provide a succinct answer. 1.01. What is the ratio of the Female students (as % of total students) of New Caledonia in 1990 to that in 1994?
Provide a short and direct response. 1. What is the ratio of the Female students (as % of total students) in San Marino in 1990 to that in 1994?
Keep it short and to the point. 0.55. What is the ratio of the Female students (as % of total students) of East Asia (all income levels) in 1990 to that in 1996?
Your answer should be very brief. 0.89. What is the ratio of the Female students (as % of total students) of San Marino in 1990 to that in 1996?
Keep it short and to the point. 0.67. What is the ratio of the Female students (as % of total students) of East Asia (all income levels) in 1990 to that in 1997?
Make the answer very short. 0.91. What is the ratio of the Female students (as % of total students) of Europe(developing only) in 1990 to that in 1997?
Your response must be concise. 1.04. What is the ratio of the Female students (as % of total students) of San Marino in 1990 to that in 1997?
Your answer should be very brief. 0.65. What is the ratio of the Female students (as % of total students) in East Asia (all income levels) in 1991 to that in 1992?
Make the answer very short. 1. What is the ratio of the Female students (as % of total students) of Europe(developing only) in 1991 to that in 1992?
Give a very brief answer. 1.01. What is the ratio of the Female students (as % of total students) in New Caledonia in 1991 to that in 1992?
Your answer should be very brief. 1. What is the ratio of the Female students (as % of total students) of East Asia (all income levels) in 1991 to that in 1993?
Provide a short and direct response. 0.99. What is the ratio of the Female students (as % of total students) in Europe(developing only) in 1991 to that in 1993?
Keep it short and to the point. 1.02. What is the ratio of the Female students (as % of total students) of New Caledonia in 1991 to that in 1993?
Offer a terse response. 1. What is the ratio of the Female students (as % of total students) of San Marino in 1991 to that in 1993?
Ensure brevity in your answer.  0.83. What is the ratio of the Female students (as % of total students) in East Asia (all income levels) in 1991 to that in 1994?
Make the answer very short. 0.92. What is the ratio of the Female students (as % of total students) in San Marino in 1991 to that in 1994?
Make the answer very short. 0.78. What is the ratio of the Female students (as % of total students) in East Asia (all income levels) in 1991 to that in 1996?
Your answer should be very brief. 0.88. What is the ratio of the Female students (as % of total students) of Europe(developing only) in 1991 to that in 1996?
Offer a very short reply. 1.04. What is the ratio of the Female students (as % of total students) in New Caledonia in 1991 to that in 1996?
Your answer should be compact. 1. What is the ratio of the Female students (as % of total students) of San Marino in 1991 to that in 1996?
Make the answer very short. 0.95. What is the ratio of the Female students (as % of total students) in East Asia (all income levels) in 1991 to that in 1997?
Provide a succinct answer. 0.9. What is the ratio of the Female students (as % of total students) of Europe(developing only) in 1991 to that in 1997?
Offer a terse response. 1.04. What is the ratio of the Female students (as % of total students) in San Marino in 1991 to that in 1997?
Your answer should be very brief. 0.92. What is the ratio of the Female students (as % of total students) of East Asia (all income levels) in 1992 to that in 1993?
Provide a short and direct response. 0.99. What is the ratio of the Female students (as % of total students) in Europe(developing only) in 1992 to that in 1993?
Offer a terse response. 1.01. What is the ratio of the Female students (as % of total students) of San Marino in 1992 to that in 1993?
Offer a terse response. 0.83. What is the ratio of the Female students (as % of total students) in East Asia (all income levels) in 1992 to that in 1994?
Ensure brevity in your answer.  0.92. What is the ratio of the Female students (as % of total students) in Europe(developing only) in 1992 to that in 1994?
Keep it short and to the point. 0.99. What is the ratio of the Female students (as % of total students) in New Caledonia in 1992 to that in 1994?
Provide a short and direct response. 1. What is the ratio of the Female students (as % of total students) in San Marino in 1992 to that in 1994?
Ensure brevity in your answer.  0.78. What is the ratio of the Female students (as % of total students) of East Asia (all income levels) in 1992 to that in 1996?
Give a very brief answer. 0.89. What is the ratio of the Female students (as % of total students) of Europe(developing only) in 1992 to that in 1996?
Make the answer very short. 1.03. What is the ratio of the Female students (as % of total students) in New Caledonia in 1992 to that in 1996?
Provide a short and direct response. 1. What is the ratio of the Female students (as % of total students) in East Asia (all income levels) in 1992 to that in 1997?
Your answer should be very brief. 0.9. What is the ratio of the Female students (as % of total students) in Europe(developing only) in 1992 to that in 1997?
Make the answer very short. 1.03. What is the ratio of the Female students (as % of total students) in New Caledonia in 1992 to that in 1997?
Your response must be concise. 1. What is the ratio of the Female students (as % of total students) in San Marino in 1992 to that in 1997?
Ensure brevity in your answer.  0.92. What is the ratio of the Female students (as % of total students) of East Asia (all income levels) in 1993 to that in 1994?
Keep it short and to the point. 0.93. What is the ratio of the Female students (as % of total students) of Europe(developing only) in 1993 to that in 1994?
Offer a terse response. 0.98. What is the ratio of the Female students (as % of total students) in San Marino in 1993 to that in 1994?
Give a very brief answer. 0.94. What is the ratio of the Female students (as % of total students) in East Asia (all income levels) in 1993 to that in 1996?
Your response must be concise. 0.89. What is the ratio of the Female students (as % of total students) in New Caledonia in 1993 to that in 1996?
Your answer should be very brief. 1. What is the ratio of the Female students (as % of total students) in San Marino in 1993 to that in 1996?
Offer a terse response. 1.14. What is the ratio of the Female students (as % of total students) in East Asia (all income levels) in 1993 to that in 1997?
Your response must be concise. 0.91. What is the ratio of the Female students (as % of total students) in Europe(developing only) in 1993 to that in 1997?
Give a very brief answer. 1.02. What is the ratio of the Female students (as % of total students) of San Marino in 1993 to that in 1997?
Offer a terse response. 1.1. What is the ratio of the Female students (as % of total students) in East Asia (all income levels) in 1994 to that in 1996?
Provide a succinct answer. 0.96. What is the ratio of the Female students (as % of total students) of Europe(developing only) in 1994 to that in 1996?
Offer a very short reply. 1.03. What is the ratio of the Female students (as % of total students) in San Marino in 1994 to that in 1996?
Provide a succinct answer. 1.22. What is the ratio of the Female students (as % of total students) in East Asia (all income levels) in 1994 to that in 1997?
Your answer should be very brief. 0.98. What is the ratio of the Female students (as % of total students) in Europe(developing only) in 1994 to that in 1997?
Provide a succinct answer. 1.04. What is the ratio of the Female students (as % of total students) in San Marino in 1994 to that in 1997?
Your response must be concise. 1.18. What is the ratio of the Female students (as % of total students) in East Asia (all income levels) in 1996 to that in 1997?
Provide a succinct answer. 1.02. What is the difference between the highest and the second highest Female students (as % of total students) in East Asia (all income levels)?
Provide a succinct answer. 0.94. What is the difference between the highest and the second highest Female students (as % of total students) in Europe(developing only)?
Keep it short and to the point. 0.11. What is the difference between the highest and the second highest Female students (as % of total students) of New Caledonia?
Offer a terse response. 0.01. What is the difference between the highest and the second highest Female students (as % of total students) in San Marino?
Give a very brief answer. 2.1. What is the difference between the highest and the lowest Female students (as % of total students) of East Asia (all income levels)?
Keep it short and to the point. 5.44. What is the difference between the highest and the lowest Female students (as % of total students) in Europe(developing only)?
Provide a short and direct response. 1.85. What is the difference between the highest and the lowest Female students (as % of total students) in New Caledonia?
Offer a very short reply. 0.23. What is the difference between the highest and the lowest Female students (as % of total students) in San Marino?
Offer a very short reply. 15.16. 